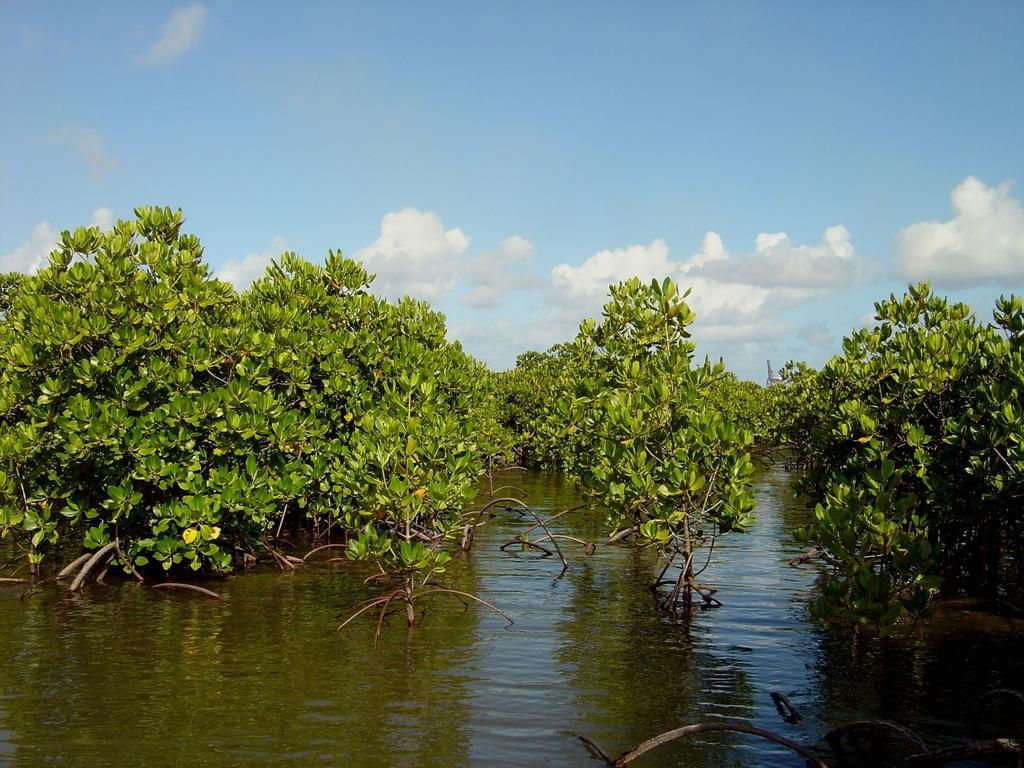Describe this image in one or two sentences. In this image I can see there are some trees visible on water at the top I can see the sky. 